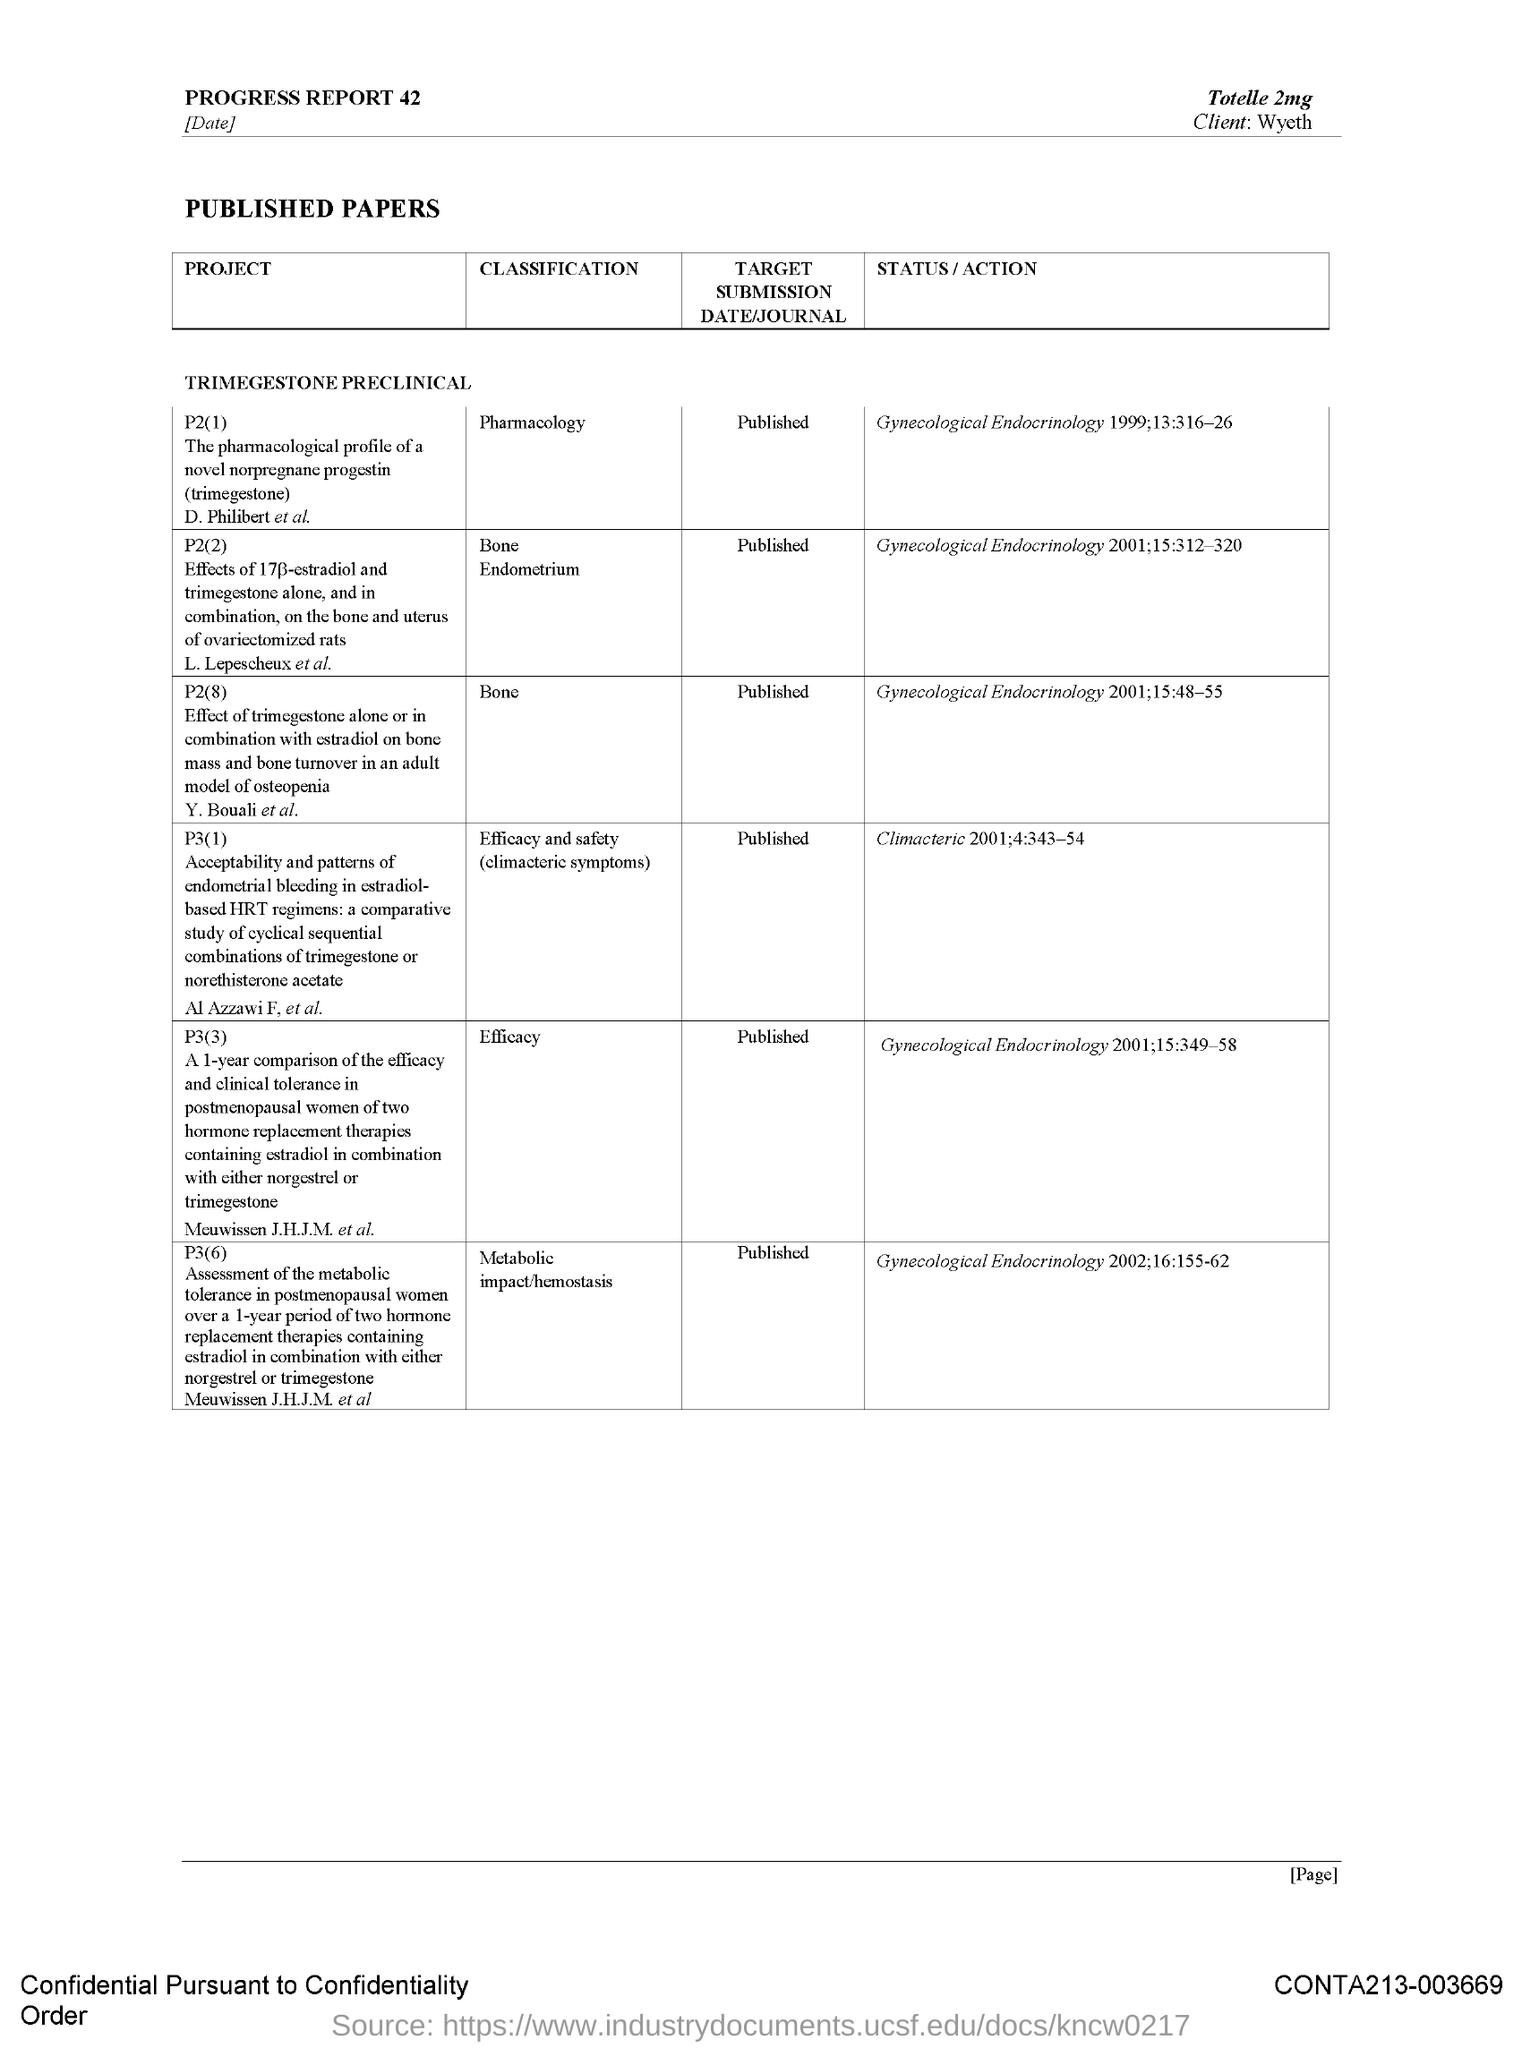Mention a couple of crucial points in this snapshot. The classification of P2(8) is "Bone". 